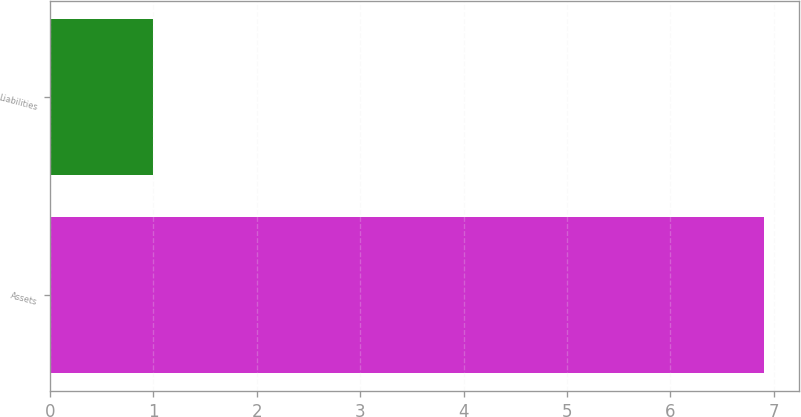<chart> <loc_0><loc_0><loc_500><loc_500><bar_chart><fcel>Assets<fcel>Liabilities<nl><fcel>6.9<fcel>1<nl></chart> 